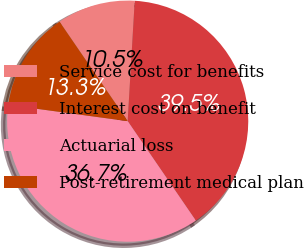Convert chart. <chart><loc_0><loc_0><loc_500><loc_500><pie_chart><fcel>Service cost for benefits<fcel>Interest cost on benefit<fcel>Actuarial loss<fcel>Post-retirement medical plan<nl><fcel>10.49%<fcel>39.51%<fcel>36.71%<fcel>13.29%<nl></chart> 